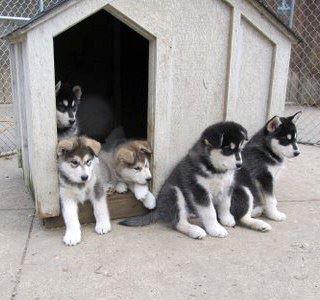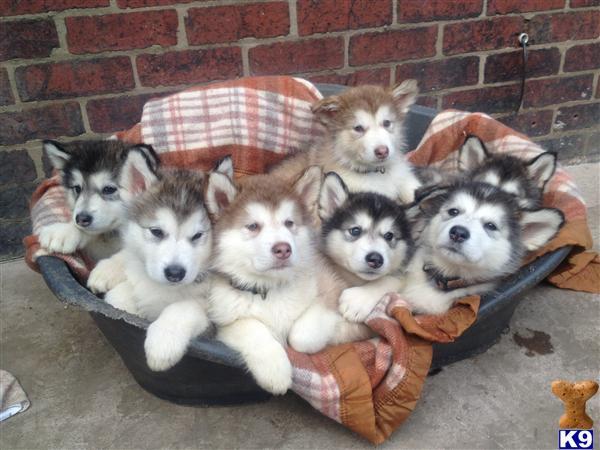The first image is the image on the left, the second image is the image on the right. For the images shown, is this caption "One of the images shows exactly five puppies." true? Answer yes or no. Yes. The first image is the image on the left, the second image is the image on the right. Considering the images on both sides, is "At least one person is standing directly next to a standing, leftward-facing husky in the left image." valid? Answer yes or no. No. 